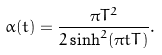Convert formula to latex. <formula><loc_0><loc_0><loc_500><loc_500>\alpha ( t ) = \frac { \pi T ^ { 2 } } { 2 \sinh ^ { 2 } ( \pi t T ) } .</formula> 